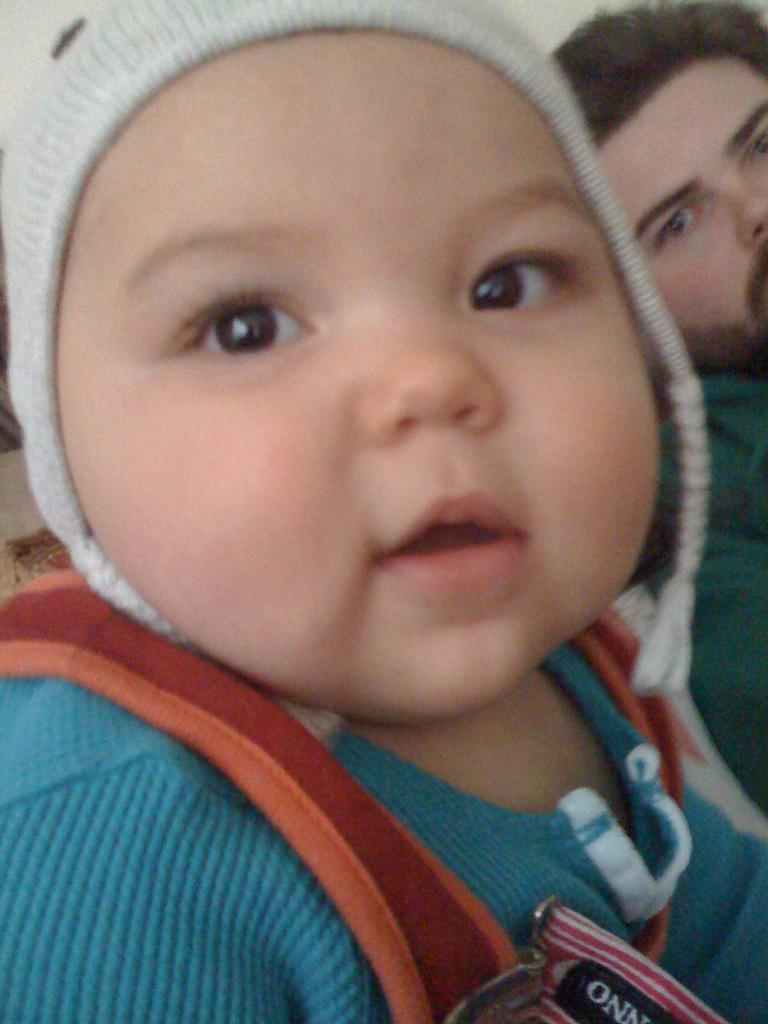What is the main subject of the image? There is a baby in the image. What is the baby wearing on his head? The baby is wearing a cap on his head. What color is the baby's t-shirt? The baby is wearing a blue color t-shirt. Can you describe the background of the image? There is a person in the background of the image. What type of whip is the baby using to sing a song in the image? There is no whip or singing activity present in the image; it features a baby wearing a cap and a blue t-shirt. 